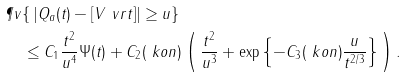Convert formula to latex. <formula><loc_0><loc_0><loc_500><loc_500>& \P v \{ \, | Q _ { a } ( t ) - [ V ^ { \ } v r t ] | \geq u \} \\ & \quad \leq C _ { 1 } \frac { t ^ { 2 } } { u ^ { 4 } } \Psi ( t ) + C _ { 2 } ( \ k o n ) \left ( \, \frac { t ^ { 2 } } { u ^ { 3 } } + \exp \left \{ - C _ { 3 } ( \ k o n ) \frac { u } { t ^ { 2 / 3 } } \right \} \, \right ) .</formula> 